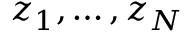<formula> <loc_0><loc_0><loc_500><loc_500>z _ { 1 } , \dots , z _ { N }</formula> 